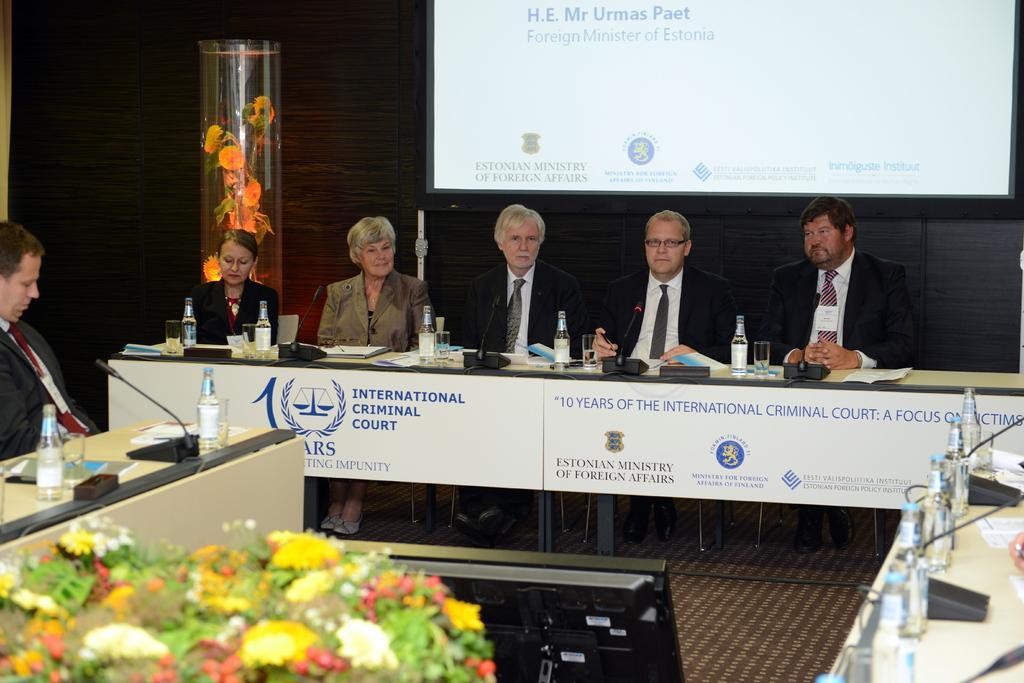Can you describe this image briefly? There are so many people sitting in chair in front of table there are bottle glass and telephone. 